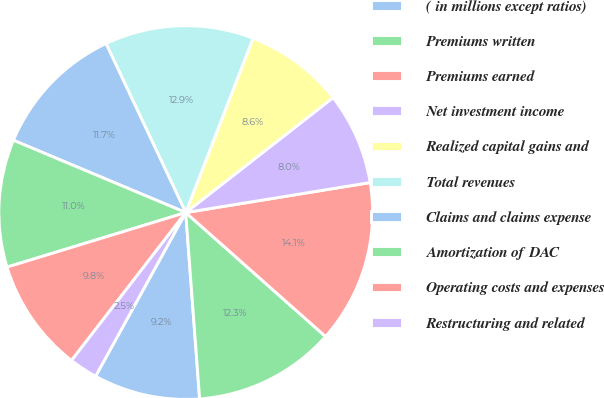Convert chart. <chart><loc_0><loc_0><loc_500><loc_500><pie_chart><fcel>( in millions except ratios)<fcel>Premiums written<fcel>Premiums earned<fcel>Net investment income<fcel>Realized capital gains and<fcel>Total revenues<fcel>Claims and claims expense<fcel>Amortization of DAC<fcel>Operating costs and expenses<fcel>Restructuring and related<nl><fcel>9.2%<fcel>12.27%<fcel>14.11%<fcel>7.98%<fcel>8.59%<fcel>12.88%<fcel>11.66%<fcel>11.04%<fcel>9.82%<fcel>2.45%<nl></chart> 